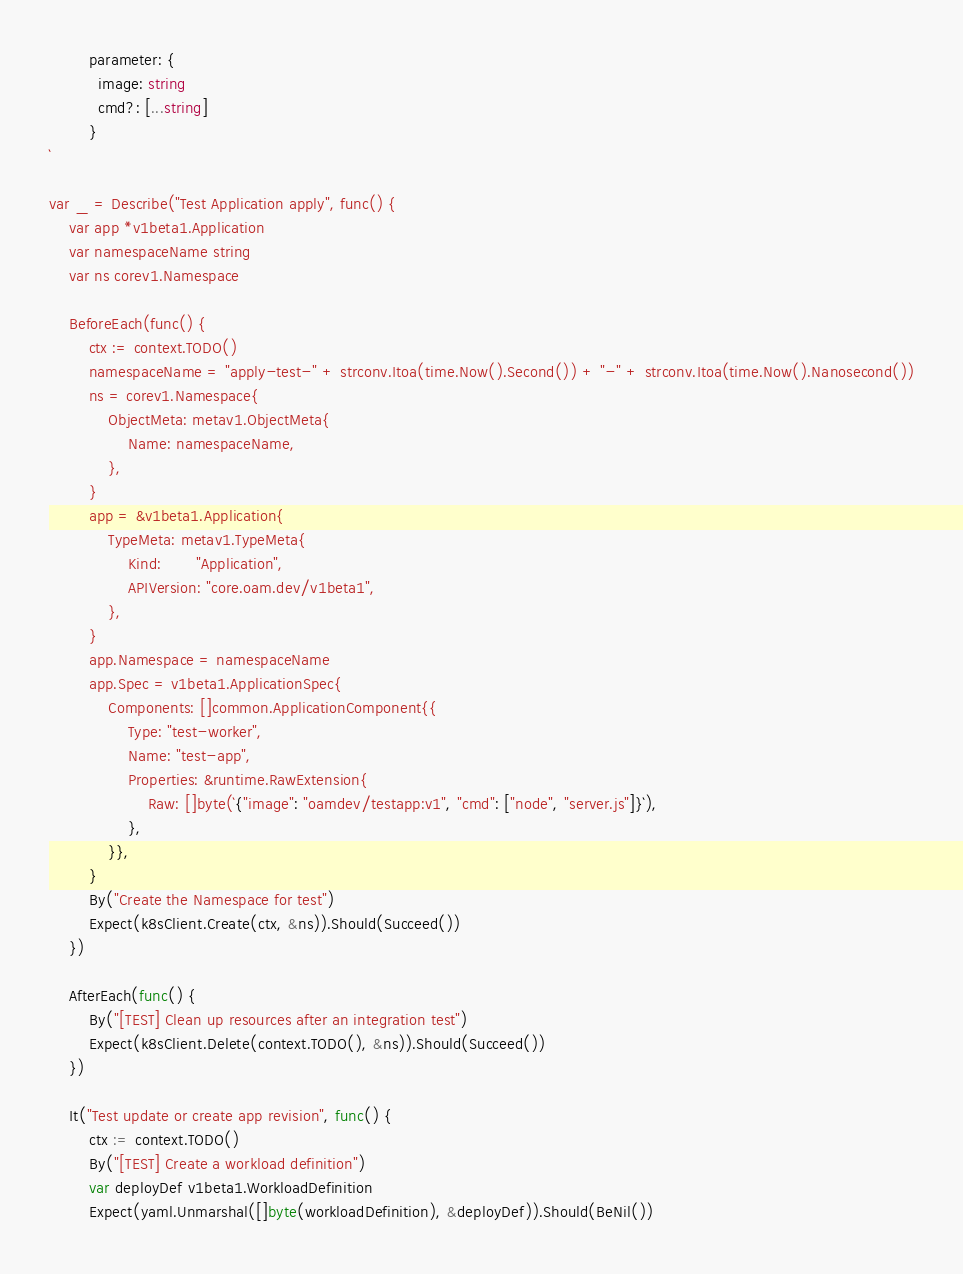<code> <loc_0><loc_0><loc_500><loc_500><_Go_>        parameter: {
          image: string
          cmd?: [...string]
        }
`

var _ = Describe("Test Application apply", func() {
	var app *v1beta1.Application
	var namespaceName string
	var ns corev1.Namespace

	BeforeEach(func() {
		ctx := context.TODO()
		namespaceName = "apply-test-" + strconv.Itoa(time.Now().Second()) + "-" + strconv.Itoa(time.Now().Nanosecond())
		ns = corev1.Namespace{
			ObjectMeta: metav1.ObjectMeta{
				Name: namespaceName,
			},
		}
		app = &v1beta1.Application{
			TypeMeta: metav1.TypeMeta{
				Kind:       "Application",
				APIVersion: "core.oam.dev/v1beta1",
			},
		}
		app.Namespace = namespaceName
		app.Spec = v1beta1.ApplicationSpec{
			Components: []common.ApplicationComponent{{
				Type: "test-worker",
				Name: "test-app",
				Properties: &runtime.RawExtension{
					Raw: []byte(`{"image": "oamdev/testapp:v1", "cmd": ["node", "server.js"]}`),
				},
			}},
		}
		By("Create the Namespace for test")
		Expect(k8sClient.Create(ctx, &ns)).Should(Succeed())
	})

	AfterEach(func() {
		By("[TEST] Clean up resources after an integration test")
		Expect(k8sClient.Delete(context.TODO(), &ns)).Should(Succeed())
	})

	It("Test update or create app revision", func() {
		ctx := context.TODO()
		By("[TEST] Create a workload definition")
		var deployDef v1beta1.WorkloadDefinition
		Expect(yaml.Unmarshal([]byte(workloadDefinition), &deployDef)).Should(BeNil())</code> 